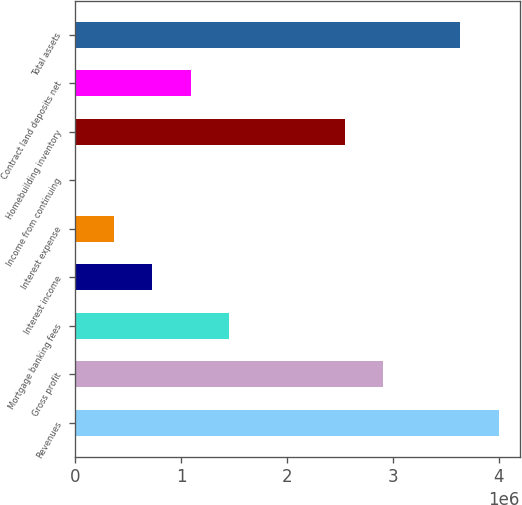Convert chart. <chart><loc_0><loc_0><loc_500><loc_500><bar_chart><fcel>Revenues<fcel>Gross profit<fcel>Mortgage banking fees<fcel>Interest income<fcel>Interest expense<fcel>Income from continuing<fcel>Homebuilding inventory<fcel>Contract land deposits net<fcel>Total assets<nl><fcel>4.00257e+06<fcel>2.91097e+06<fcel>1.45549e+06<fcel>727754<fcel>363886<fcel>17.04<fcel>2.5471e+06<fcel>1.09162e+06<fcel>3.6387e+06<nl></chart> 